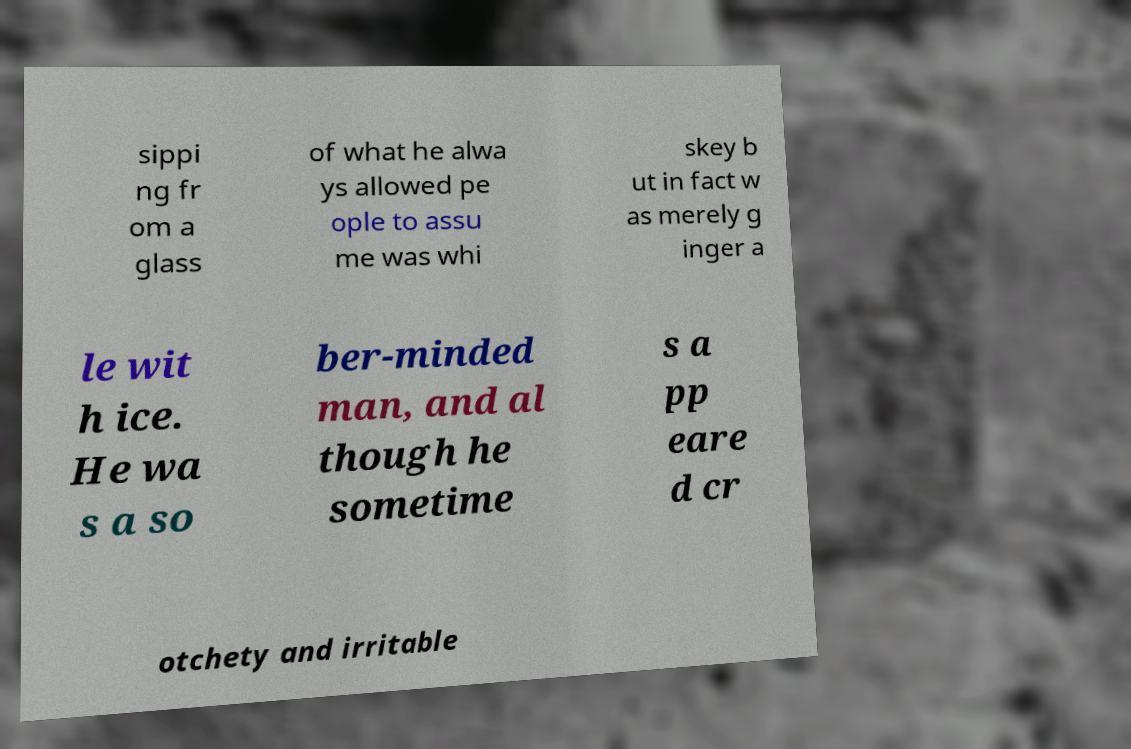Could you assist in decoding the text presented in this image and type it out clearly? sippi ng fr om a glass of what he alwa ys allowed pe ople to assu me was whi skey b ut in fact w as merely g inger a le wit h ice. He wa s a so ber-minded man, and al though he sometime s a pp eare d cr otchety and irritable 